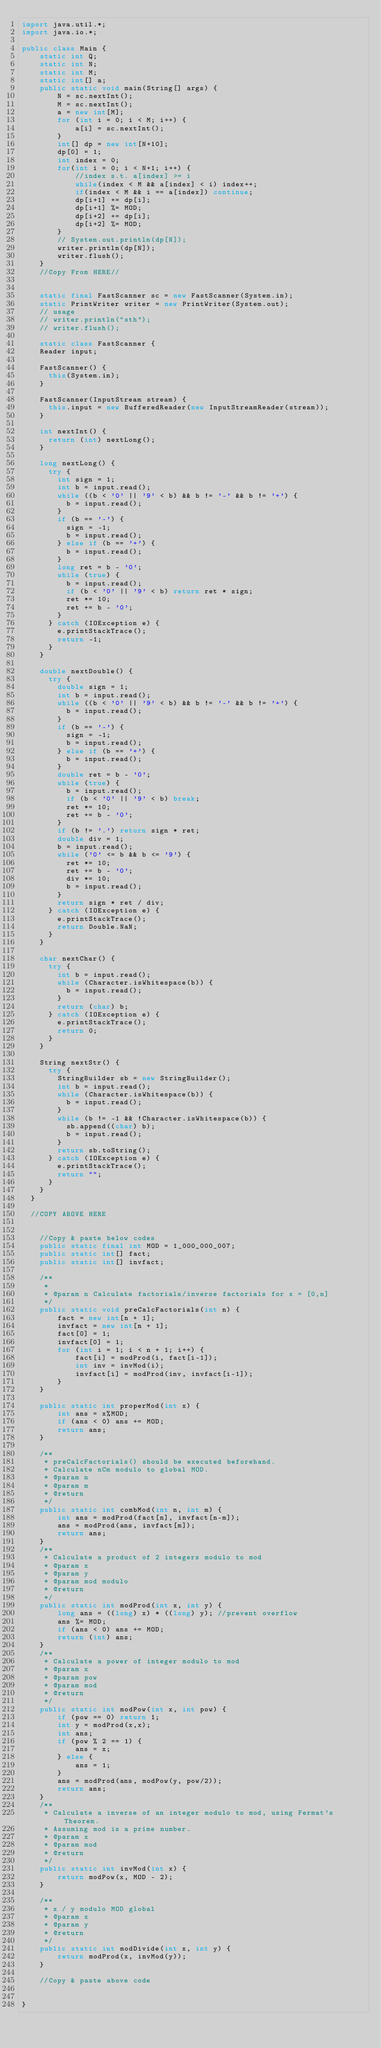Convert code to text. <code><loc_0><loc_0><loc_500><loc_500><_Java_>import java.util.*;
import java.io.*;

public class Main {
    static int Q;
    static int N;
    static int M;
    static int[] a;
    public static void main(String[] args) {
        N = sc.nextInt();
        M = sc.nextInt();
        a = new int[M];
        for (int i = 0; i < M; i++) {
            a[i] = sc.nextInt();
        }
        int[] dp = new int[N+10];
        dp[0] = 1;
        int index = 0;
        for(int i = 0; i < N+1; i++) {
            //index s.t. a[index] >= i
            while(index < M && a[index] < i) index++;
            if(index < M && i == a[index]) continue;
            dp[i+1] += dp[i];
            dp[i+1] %= MOD;
            dp[i+2] += dp[i];
            dp[i+2] %= MOD;
        }
        // System.out.println(dp[N]);
        writer.println(dp[N]);
        writer.flush();
    }
		//Copy From HERE//


    static final FastScanner sc = new FastScanner(System.in);
    static PrintWriter writer = new PrintWriter(System.out);
    // usage
    // writer.println("sth");
    // writer.flush();

    static class FastScanner {
		Reader input;
 
		FastScanner() {
			this(System.in);
		}
 
		FastScanner(InputStream stream) {
			this.input = new BufferedReader(new InputStreamReader(stream));
		}
 
		int nextInt() {
			return (int) nextLong();
		}
 
		long nextLong() {
			try {
				int sign = 1;
				int b = input.read();
				while ((b < '0' || '9' < b) && b != '-' && b != '+') {
					b = input.read();
				}
				if (b == '-') {
					sign = -1;
					b = input.read();
				} else if (b == '+') {
					b = input.read();
				}
				long ret = b - '0';
				while (true) {
					b = input.read();
					if (b < '0' || '9' < b) return ret * sign;
					ret *= 10;
					ret += b - '0';
				}
			} catch (IOException e) {
				e.printStackTrace();
				return -1;
			}
		}
 
		double nextDouble() {
			try {
				double sign = 1;
				int b = input.read();
				while ((b < '0' || '9' < b) && b != '-' && b != '+') {
					b = input.read();
				}
				if (b == '-') {
					sign = -1;
					b = input.read();
				} else if (b == '+') {
					b = input.read();
				}
				double ret = b - '0';
				while (true) {
					b = input.read();
					if (b < '0' || '9' < b) break;
					ret *= 10;
					ret += b - '0';
				}
				if (b != '.') return sign * ret;
				double div = 1;
				b = input.read();
				while ('0' <= b && b <= '9') {
					ret *= 10;
					ret += b - '0';
					div *= 10;
					b = input.read();
				}
				return sign * ret / div;
			} catch (IOException e) {
				e.printStackTrace();
				return Double.NaN;
			}
		}
 
		char nextChar() {
			try {
				int b = input.read();
				while (Character.isWhitespace(b)) {
					b = input.read();
				}
				return (char) b;
			} catch (IOException e) {
				e.printStackTrace();
				return 0;
			}
		}
 
		String nextStr() {
			try {
				StringBuilder sb = new StringBuilder();
				int b = input.read();
				while (Character.isWhitespace(b)) {
					b = input.read();
				}
				while (b != -1 && !Character.isWhitespace(b)) {
					sb.append((char) b);
					b = input.read();
				}
				return sb.toString();
			} catch (IOException e) {
				e.printStackTrace();
				return "";
			}
		}
	}

	//COPY ABOVE HERE


    //Copy & paste below codes
    public static final int MOD = 1_000_000_007;
    public static int[] fact;
    public static int[] invfact;

    /**
     * 
     * @param n Calculate factorials/inverse factorials for x = [0,n]
     */
    public static void preCalcFactorials(int n) {
        fact = new int[n + 1];
        invfact = new int[n + 1];
        fact[0] = 1;
        invfact[0] = 1;
        for (int i = 1; i < n + 1; i++) {
            fact[i] = modProd(i, fact[i-1]);
            int inv = invMod(i);
            invfact[i] = modProd(inv, invfact[i-1]);
        }
    }

    public static int properMod(int x) {
        int ans = x%MOD;
        if (ans < 0) ans += MOD;
        return ans;
    }

    /**
     * preCalcFactorials() should be executed beforehand.
     * Calculate nCm modulo to global MOD.
     * @param n
     * @param m
     * @return
     */
    public static int combMod(int n, int m) {
        int ans = modProd(fact[n], invfact[n-m]);
        ans = modProd(ans, invfact[m]);
        return ans;
    }
    /**
     * Calculate a product of 2 integers modulo to mod
     * @param x
     * @param y
     * @param mod modulo
     * @return
     */
    public static int modProd(int x, int y) {
        long ans = ((long) x) * ((long) y); //prevent overflow
        ans %= MOD;
        if (ans < 0) ans += MOD;
        return (int) ans;
    }
    /**
     * Calculate a power of integer modulo to mod
     * @param x
     * @param pow
     * @param mod
     * @return
     */
    public static int modPow(int x, int pow) {
        if (pow == 0) return 1;
        int y = modProd(x,x);
        int ans; 
        if (pow % 2 == 1) {
            ans = x;
        } else {
            ans = 1;
        }
        ans = modProd(ans, modPow(y, pow/2));
        return ans;
    }
    /**
     * Calculate a inverse of an integer modulo to mod, using Fermat's Theorem.
     * Assuming mod is a prime number.
     * @param x
     * @param mod
     * @return
     */
    public static int invMod(int x) {
        return modPow(x, MOD - 2);
    }

    /**
     * x / y modulo MOD global
     * @param x
     * @param y
     * @return
     */
    public static int modDivide(int x, int y) {
        return modProd(x, invMod(y));
    }

    //Copy & paste above code


}
</code> 